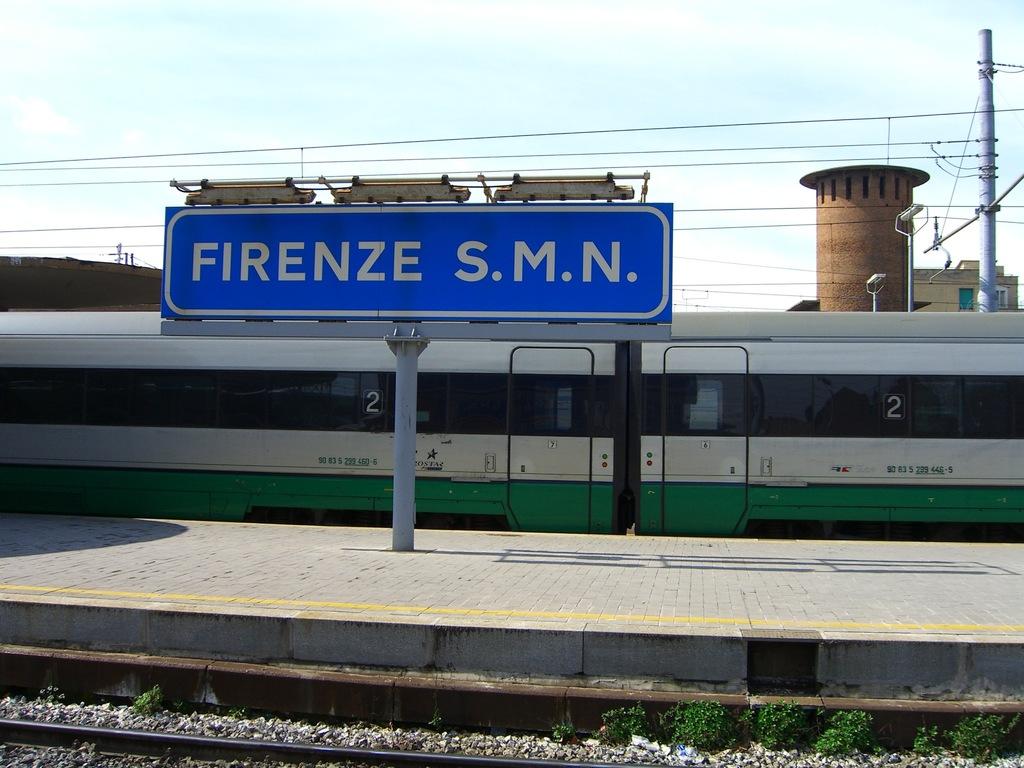Which station is this?
Ensure brevity in your answer.  Firenze s.m.n. What are the three letters on the right?
Provide a succinct answer. Smn. 